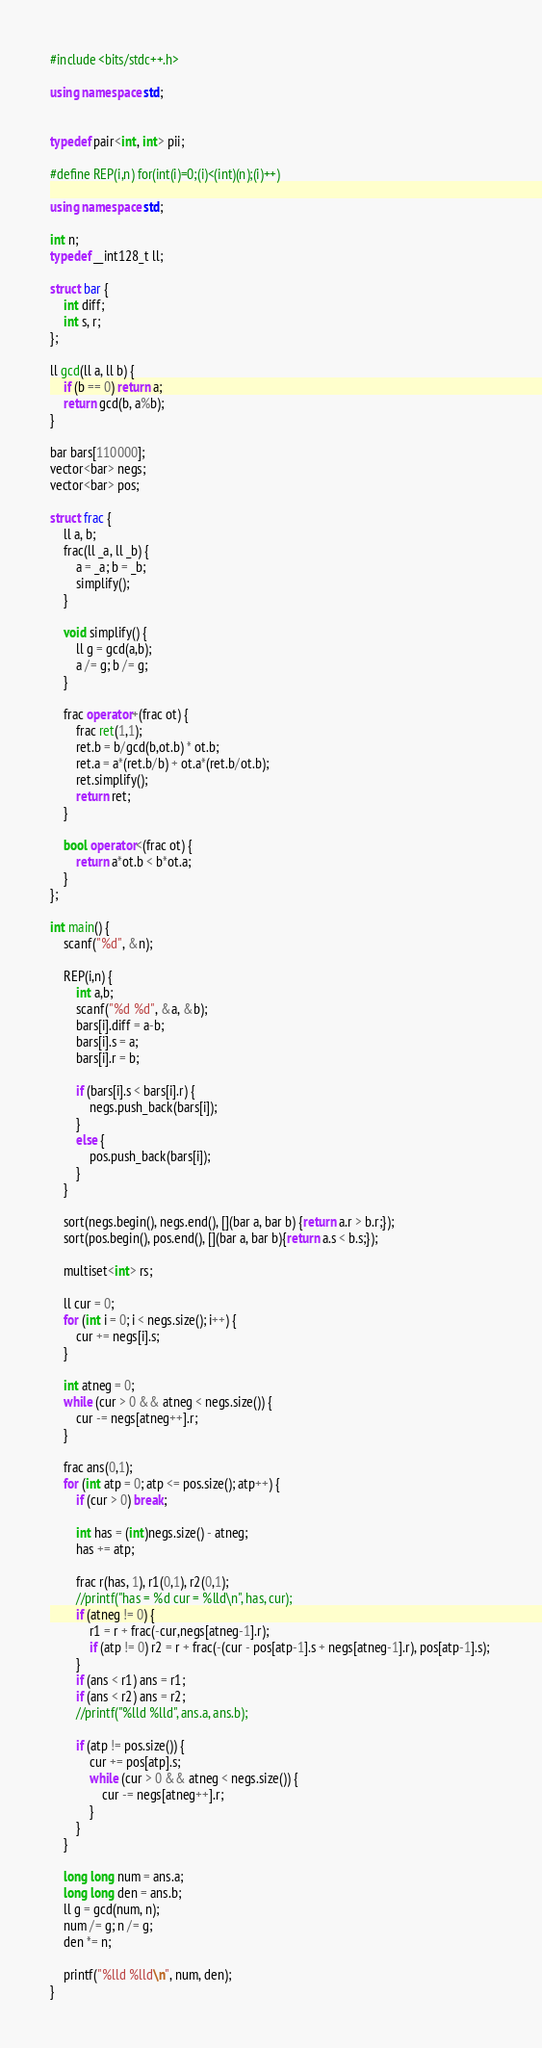Convert code to text. <code><loc_0><loc_0><loc_500><loc_500><_C++_>#include <bits/stdc++.h> 

using namespace std;


typedef pair<int, int> pii;

#define REP(i,n) for(int(i)=0;(i)<(int)(n);(i)++)

using namespace std;

int n;
typedef __int128_t ll;

struct bar {
	int diff;
	int s, r;
};

ll gcd(ll a, ll b) {
	if (b == 0) return a;
	return gcd(b, a%b);
}

bar bars[110000];
vector<bar> negs;
vector<bar> pos;

struct frac {
	ll a, b;
	frac(ll _a, ll _b) {
		a = _a; b = _b;
		simplify();
	}

	void simplify() {
		ll g = gcd(a,b);
		a /= g; b /= g;
	}

	frac operator+(frac ot) {
		frac ret(1,1);
		ret.b = b/gcd(b,ot.b) * ot.b;
		ret.a = a*(ret.b/b) + ot.a*(ret.b/ot.b);
		ret.simplify();
		return ret;
	}

	bool operator<(frac ot) {
		return a*ot.b < b*ot.a;
	}
};

int main() {
	scanf("%d", &n);

	REP(i,n) {
		int a,b;
		scanf("%d %d", &a, &b);
		bars[i].diff = a-b;
		bars[i].s = a;
		bars[i].r = b;
	
		if (bars[i].s < bars[i].r) {
			negs.push_back(bars[i]);
		}
		else {
			pos.push_back(bars[i]);
		}
	}

	sort(negs.begin(), negs.end(), [](bar a, bar b) {return a.r > b.r;});
	sort(pos.begin(), pos.end(), [](bar a, bar b){return a.s < b.s;});

	multiset<int> rs;

	ll cur = 0;
	for (int i = 0; i < negs.size(); i++) {
		cur += negs[i].s;
	}

	int atneg = 0;
	while (cur > 0 && atneg < negs.size()) {
		cur -= negs[atneg++].r;
	}

	frac ans(0,1);
	for (int atp = 0; atp <= pos.size(); atp++) {
		if (cur > 0) break;

		int has = (int)negs.size() - atneg;
		has += atp;

		frac r(has, 1), r1(0,1), r2(0,1);
		//printf("has = %d cur = %lld\n", has, cur);
		if (atneg != 0) {
			r1 = r + frac(-cur,negs[atneg-1].r);
			if (atp != 0) r2 = r + frac(-(cur - pos[atp-1].s + negs[atneg-1].r), pos[atp-1].s); 
		}
		if (ans < r1) ans = r1;
		if (ans < r2) ans = r2;
		//printf("%lld %lld", ans.a, ans.b);

		if (atp != pos.size()) {
			cur += pos[atp].s;
			while (cur > 0 && atneg < negs.size()) {
				cur -= negs[atneg++].r;
			}
		}
	}

	long long num = ans.a;
	long long den = ans.b;
	ll g = gcd(num, n);
	num /= g; n /= g;
	den *= n;

	printf("%lld %lld\n", num, den);
}</code> 